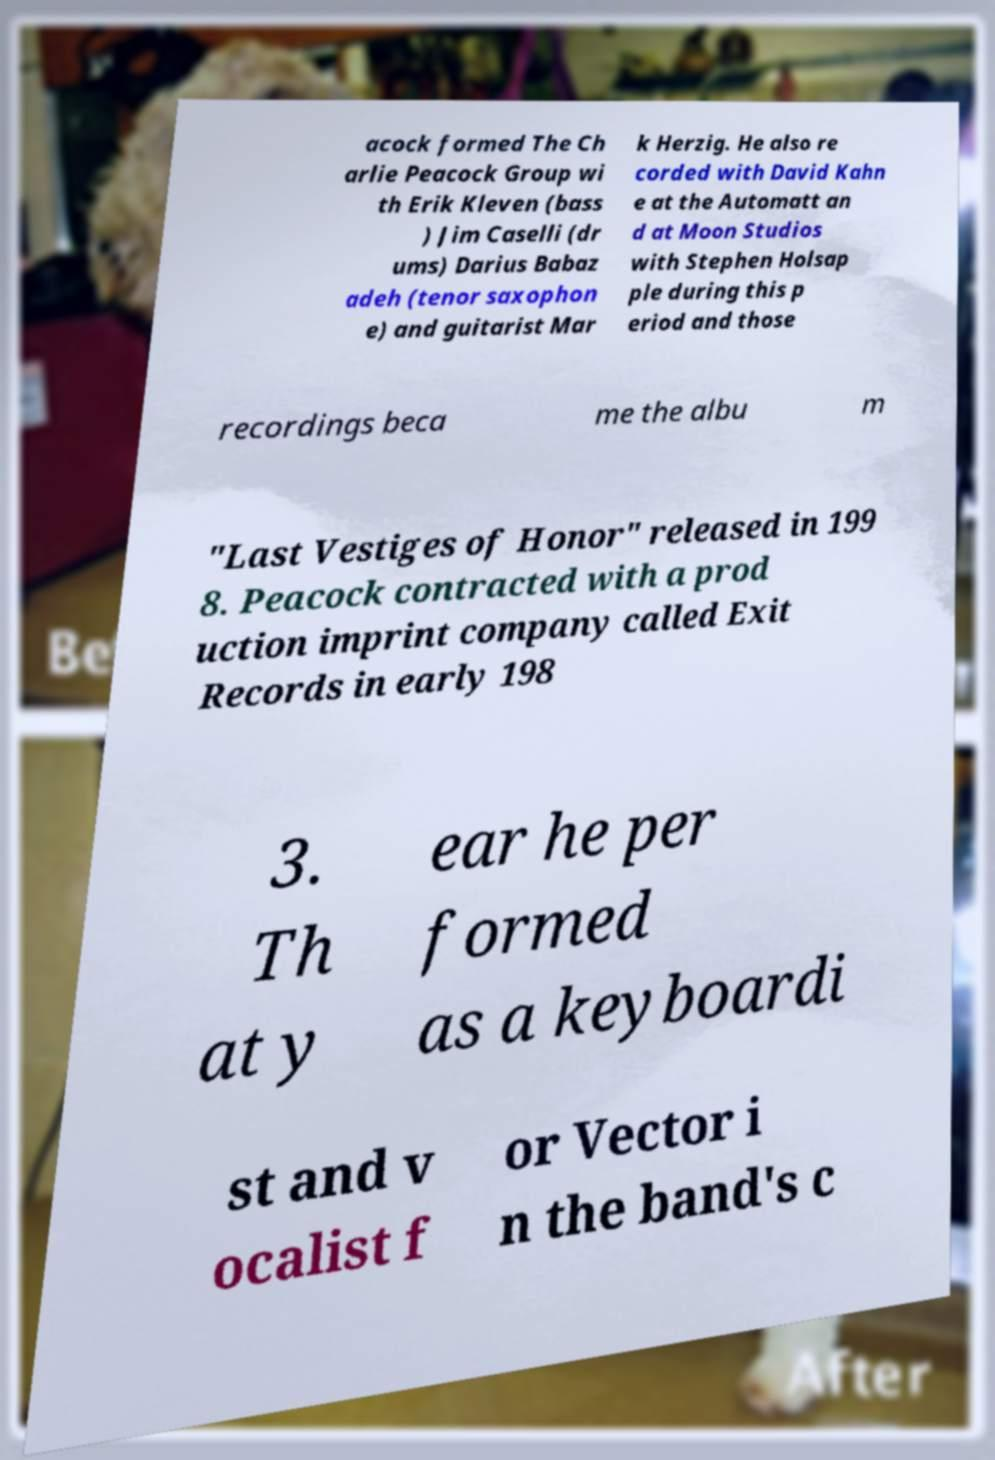Please read and relay the text visible in this image. What does it say? acock formed The Ch arlie Peacock Group wi th Erik Kleven (bass ) Jim Caselli (dr ums) Darius Babaz adeh (tenor saxophon e) and guitarist Mar k Herzig. He also re corded with David Kahn e at the Automatt an d at Moon Studios with Stephen Holsap ple during this p eriod and those recordings beca me the albu m "Last Vestiges of Honor" released in 199 8. Peacock contracted with a prod uction imprint company called Exit Records in early 198 3. Th at y ear he per formed as a keyboardi st and v ocalist f or Vector i n the band's c 